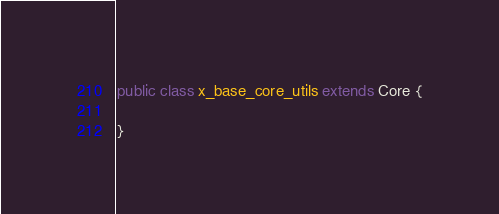<code> <loc_0><loc_0><loc_500><loc_500><_Java_>public class x_base_core_utils extends Core {

}
</code> 